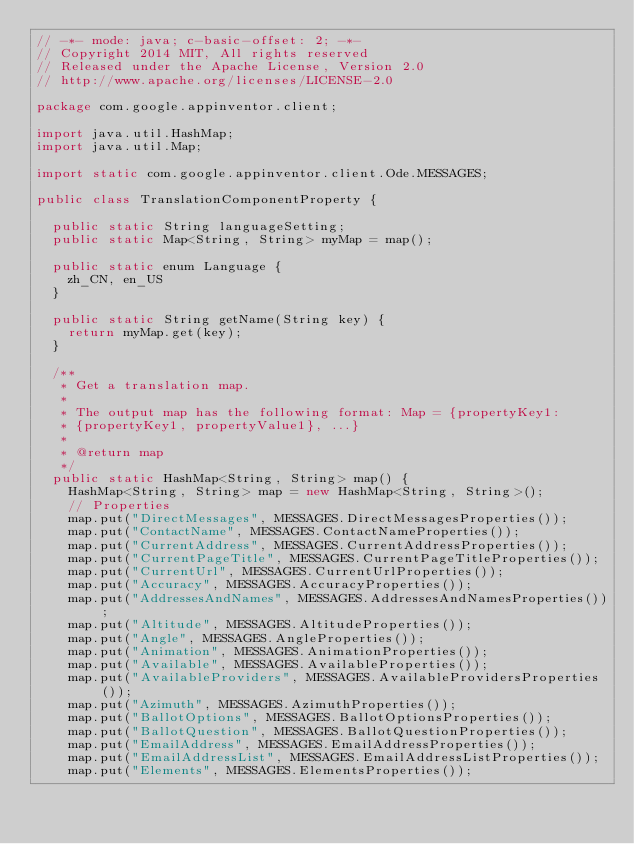Convert code to text. <code><loc_0><loc_0><loc_500><loc_500><_Java_>// -*- mode: java; c-basic-offset: 2; -*-
// Copyright 2014 MIT, All rights reserved
// Released under the Apache License, Version 2.0
// http://www.apache.org/licenses/LICENSE-2.0

package com.google.appinventor.client;

import java.util.HashMap;
import java.util.Map;

import static com.google.appinventor.client.Ode.MESSAGES;

public class TranslationComponentProperty {

  public static String languageSetting;
  public static Map<String, String> myMap = map();

  public static enum Language {
    zh_CN, en_US
  }

  public static String getName(String key) {
    return myMap.get(key);
  }

  /**
   * Get a translation map.
   *
   * The output map has the following format: Map = {propertyKey1:
   * {propertyKey1, propertyValue1}, ...}
   *
   * @return map
   */
  public static HashMap<String, String> map() {
    HashMap<String, String> map = new HashMap<String, String>();
    // Properties
    map.put("DirectMessages", MESSAGES.DirectMessagesProperties());
    map.put("ContactName", MESSAGES.ContactNameProperties());
    map.put("CurrentAddress", MESSAGES.CurrentAddressProperties());
    map.put("CurrentPageTitle", MESSAGES.CurrentPageTitleProperties());
    map.put("CurrentUrl", MESSAGES.CurrentUrlProperties());
    map.put("Accuracy", MESSAGES.AccuracyProperties());
    map.put("AddressesAndNames", MESSAGES.AddressesAndNamesProperties());
    map.put("Altitude", MESSAGES.AltitudeProperties());
    map.put("Angle", MESSAGES.AngleProperties());
    map.put("Animation", MESSAGES.AnimationProperties());
    map.put("Available", MESSAGES.AvailableProperties());
    map.put("AvailableProviders", MESSAGES.AvailableProvidersProperties());
    map.put("Azimuth", MESSAGES.AzimuthProperties());
    map.put("BallotOptions", MESSAGES.BallotOptionsProperties());
    map.put("BallotQuestion", MESSAGES.BallotQuestionProperties());
    map.put("EmailAddress", MESSAGES.EmailAddressProperties());
    map.put("EmailAddressList", MESSAGES.EmailAddressListProperties());
    map.put("Elements", MESSAGES.ElementsProperties());</code> 